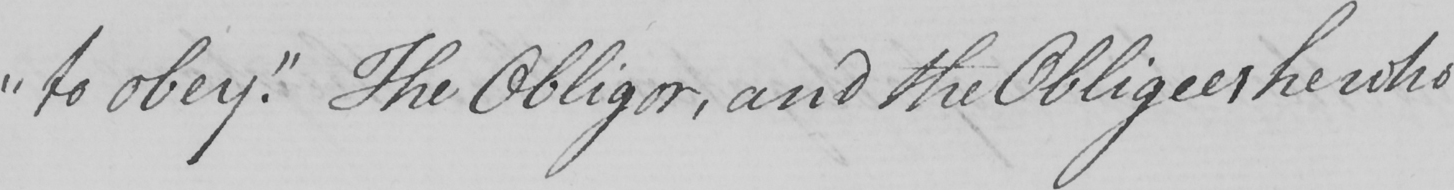Please provide the text content of this handwritten line. " to obey . "  The Obligor , and the Obligee , he who 